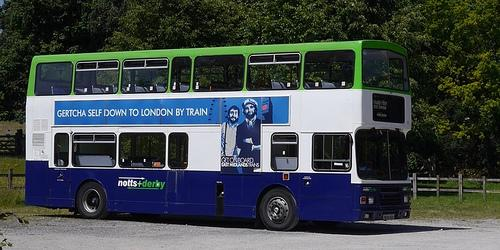What is the primary mode of transportation depicted in the image? The primary mode of transportation depicted is a blue, white, and green double decker bus driving down a road. Mention the most distinct features of the vehicle in the image. The bus is a double decker with blue, white, and green coloring, large windshield, many windows, an advertisement on the side, and black tires. Enumerate the main elements in the image and their colors. Double decker bus, blue white and green; fence, wooden; trees, green; road, stone pavement; advertisement, various colors. What prominent features are visible on the exterior of the bus? The windshield, headlights, advertisement, black tires, and many windows are visible on the bus exterior. Briefly describe the scene portrayed in the image. A double decker bus is driving down a road, with a wooden fence and green trees behind it, and several features, such as windows and an advertisement, are visible. Outline the key elements in the image and elaborate on the bus's unique features. A double decker bus with blue, white, and green coloring, large windshield, several windows, black tires, and an advertisement is driving down a wooded road with a wooden fence and green trees in the background. Describe the appearance of the bus and its notable parts. The bus is blue on the bottom, white in the middle, and green on the top, with black tires, a large windshield, several windows, an advertisement, and headlights. Summarize the scene depicted in the image in one sentence. A colorful double decker bus drives down a wooded road, showcasing various features such as an advertisement, windows, and headlights. In a concise manner, depict the vehicle's environment. The bus is surrounded by a wooden fence, lush green trees, and a stone paved road. Explain the setting of this image. The image shows a doubledecker bus driving down a wooded road with a wooden fence and lush green trees in the background. 